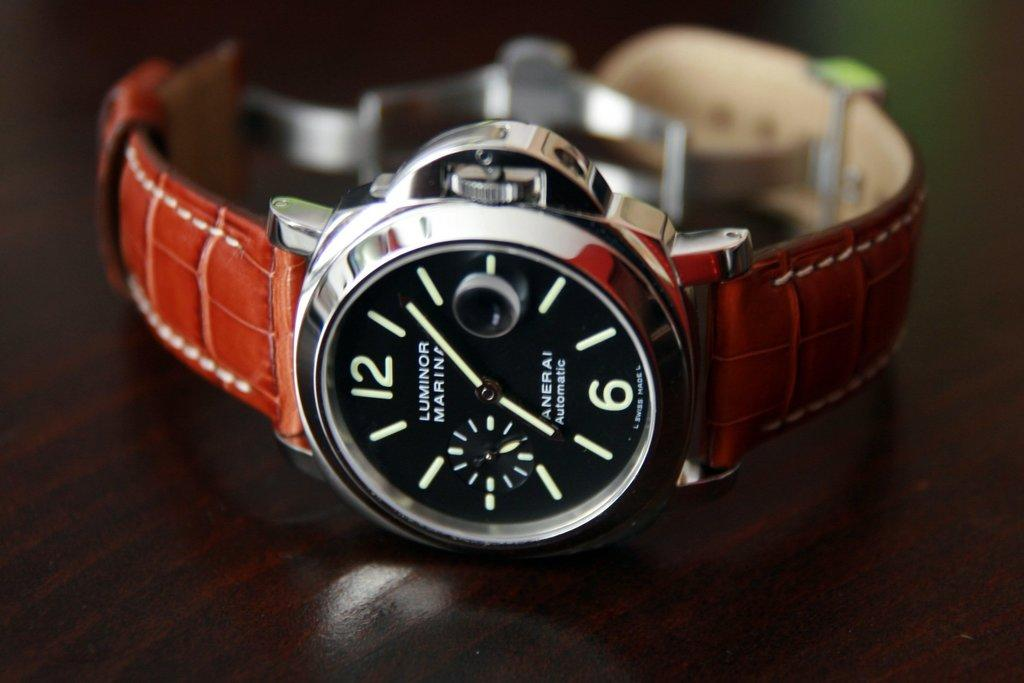<image>
Provide a brief description of the given image. A watch face has a brown band and the word luminor on the front. 